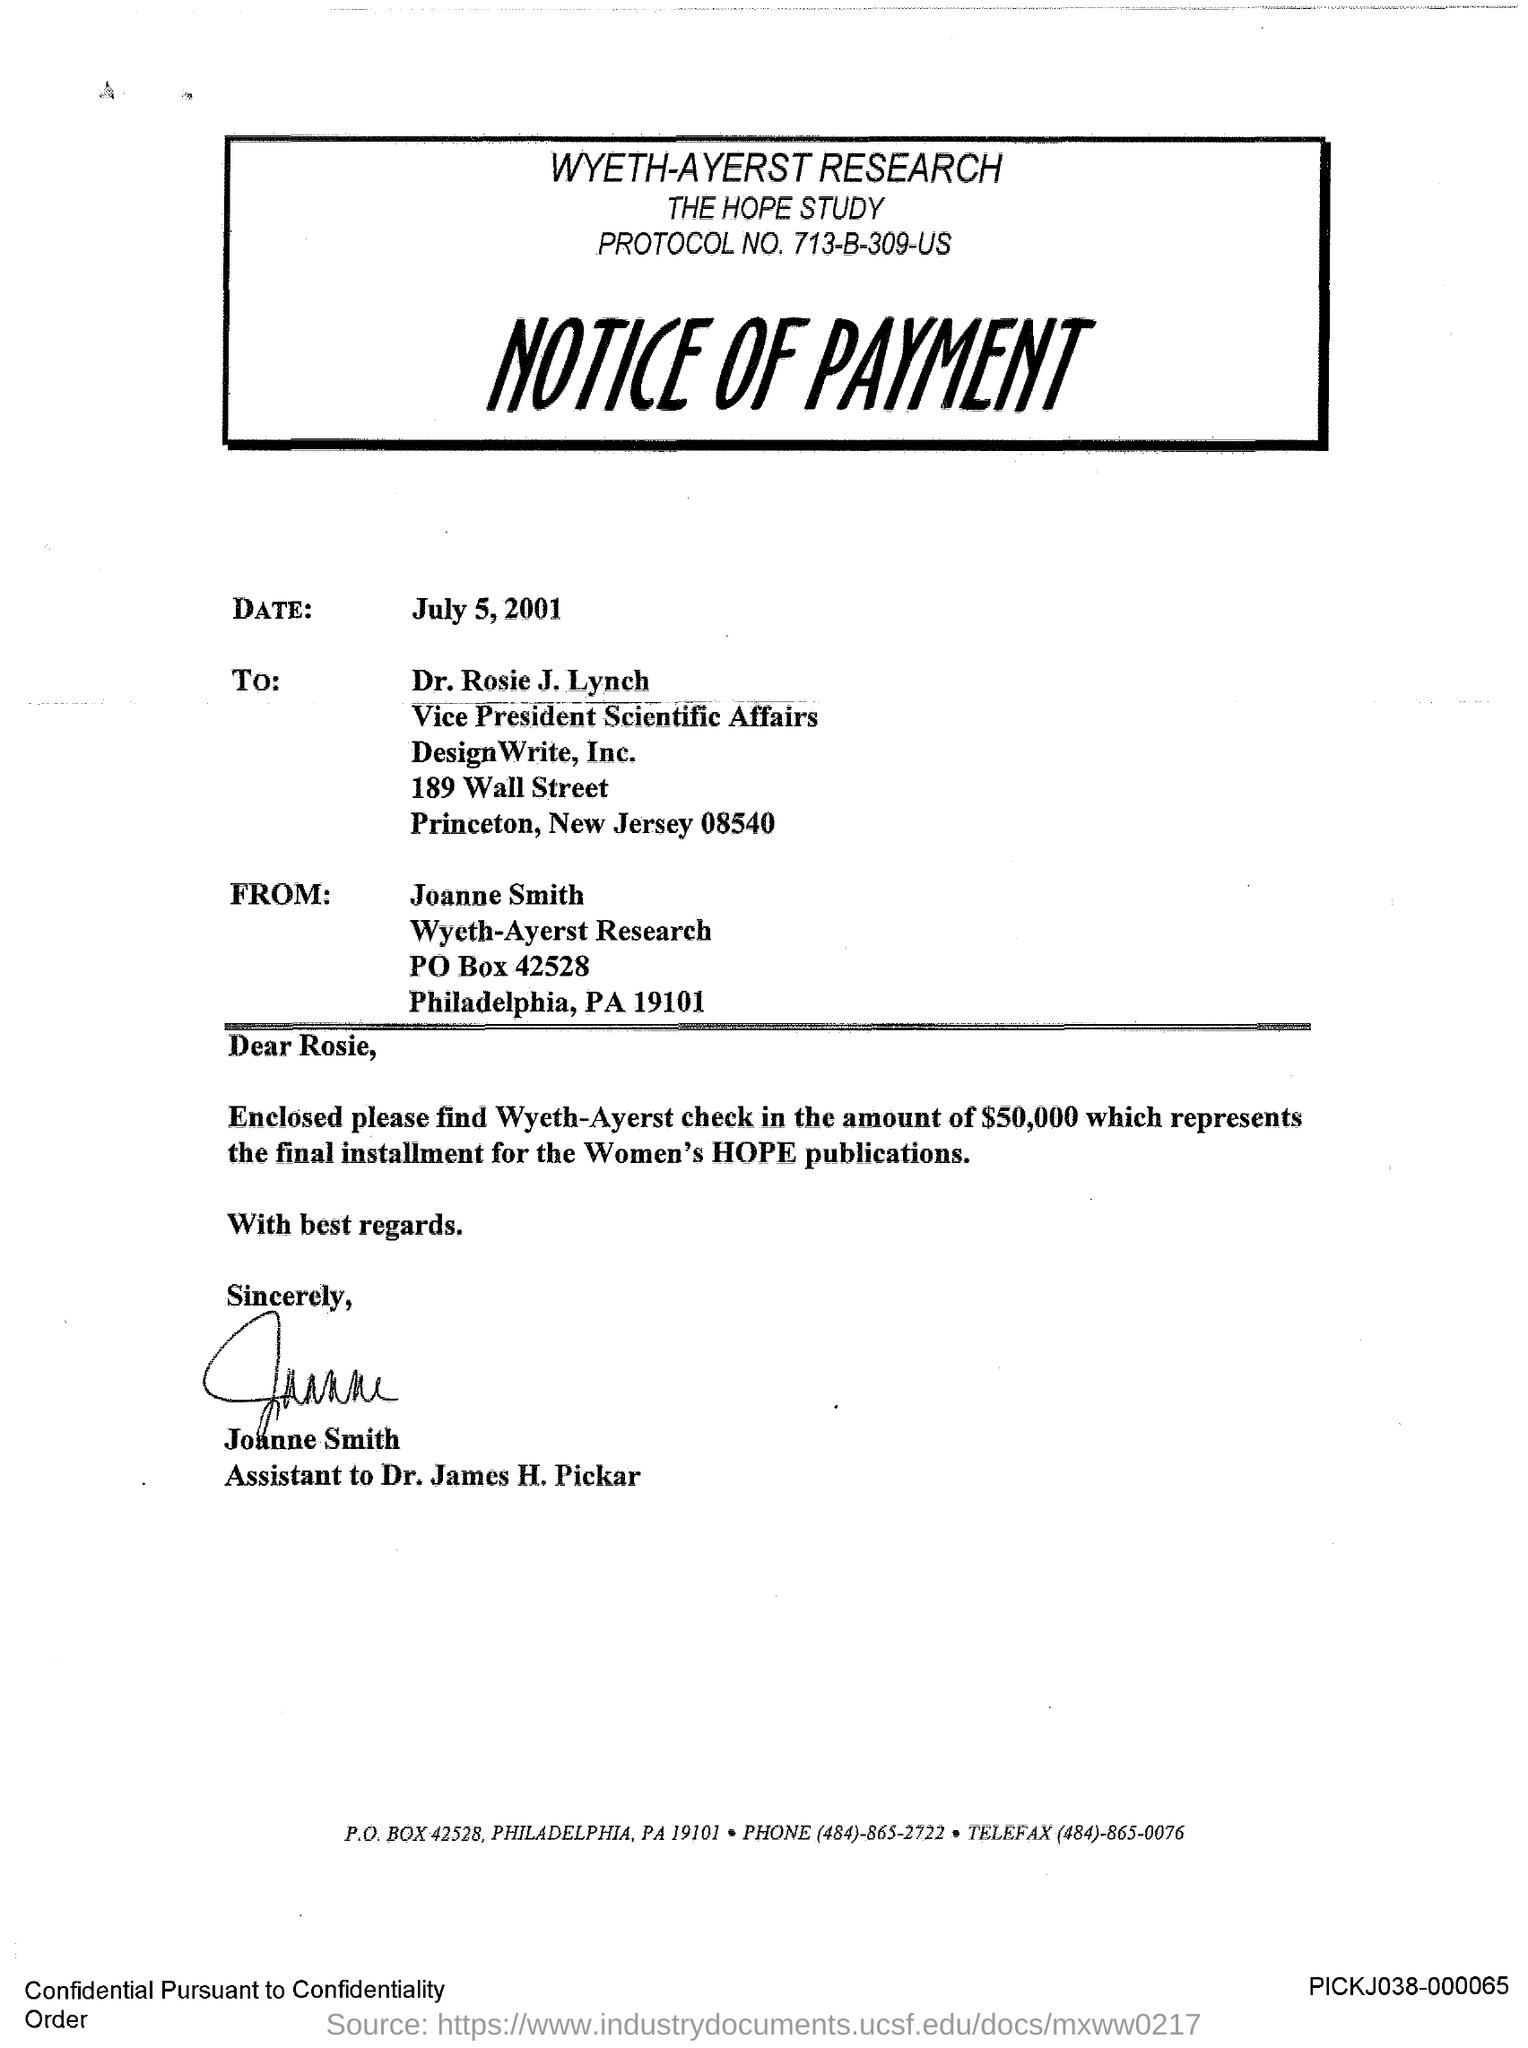What is the headding?
Your response must be concise. WYETH-AYERST RESEARCH. What is the date?
Provide a succinct answer. July 5, 2001. What is the salutation of this letter?
Keep it short and to the point. Dear Rosie,. 